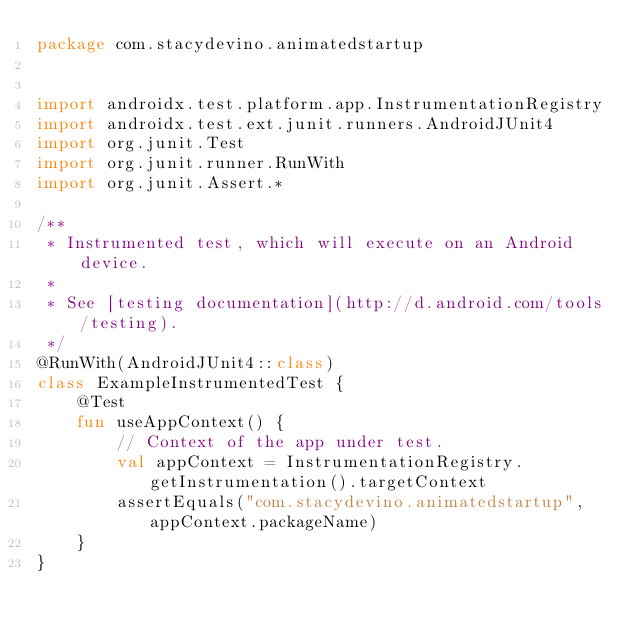Convert code to text. <code><loc_0><loc_0><loc_500><loc_500><_Kotlin_>package com.stacydevino.animatedstartup


import androidx.test.platform.app.InstrumentationRegistry
import androidx.test.ext.junit.runners.AndroidJUnit4
import org.junit.Test
import org.junit.runner.RunWith
import org.junit.Assert.*

/**
 * Instrumented test, which will execute on an Android device.
 *
 * See [testing documentation](http://d.android.com/tools/testing).
 */
@RunWith(AndroidJUnit4::class)
class ExampleInstrumentedTest {
    @Test
    fun useAppContext() {
        // Context of the app under test.
        val appContext = InstrumentationRegistry.getInstrumentation().targetContext
        assertEquals("com.stacydevino.animatedstartup", appContext.packageName)
    }
}</code> 